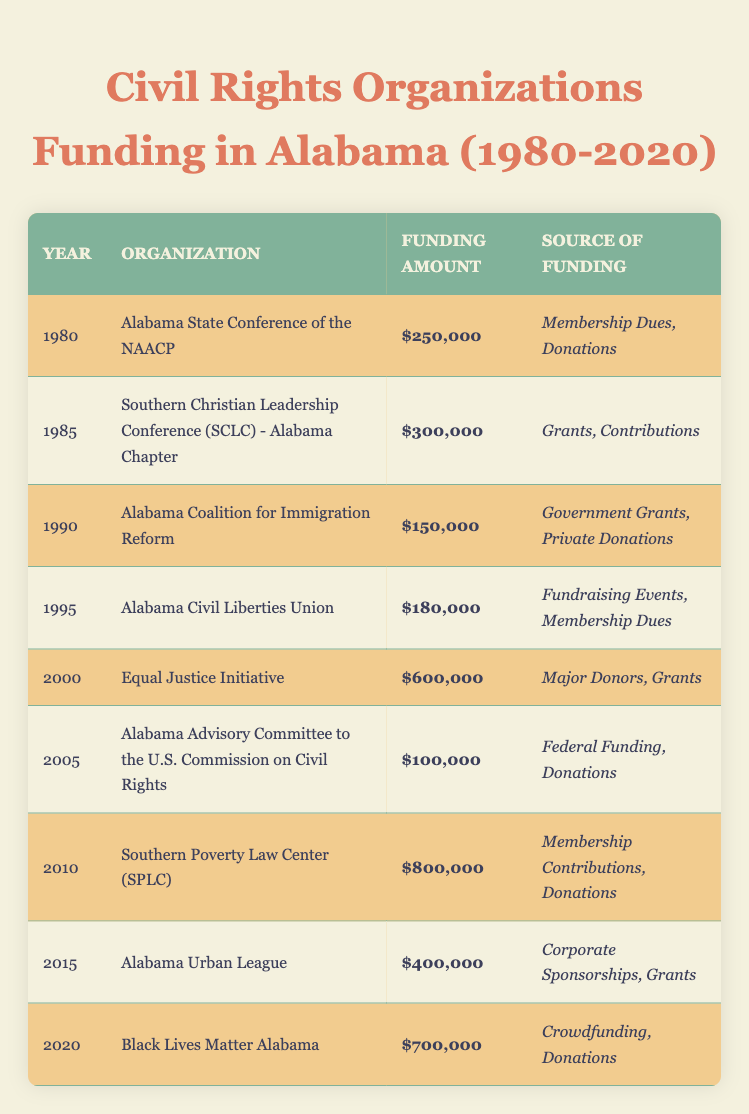What is the highest funding amount listed for a civil rights organization in Alabama between 1980 and 2020? The highest funding amount in the table is $800,000 for the Southern Poverty Law Center (SPLC) in 2010.
Answer: $800,000 Which organization received funding in 2005 and what was the amount? The Alabama Advisory Committee to the U.S. Commission on Civil Rights received $100,000 in 2005.
Answer: $100,000 What was the total funding amount for all organizations in the year 2000? In 2000, the funding amount was only $600,000 from the Equal Justice Initiative as it is the only entry for that year.
Answer: $600,000 Did the funding for the Black Lives Matter Alabama organization increase from 2015 to 2020? Yes, in 2015 the Alabama Urban League received $400,000 and in 2020 the Black Lives Matter Alabama received $700,000, showing an increase of $300,000.
Answer: Yes What is the average funding amount for civil rights organizations from 1980 to 2020? The funding amounts are $250,000, $300,000, $150,000, $180,000, $600,000, $100,000, $800,000, $400,000, and $700,000. The total is $3,480,000 and there are 9 organizations, so the average is $3,480,000 divided by 9, which equals $386,666.67.
Answer: $386,666.67 Which year saw the smallest funding amount and which organization was it? The smallest funding amount was $100,000 in 2005 for the Alabama Advisory Committee to the U.S. Commission on Civil Rights.
Answer: 2005, Alabama Advisory Committee to the U.S. Commission on Civil Rights How many organizations received funding of $600,000 or more? There are three organizations that received $600,000 or more: the Equal Justice Initiative in 2000 ($600,000), the Southern Poverty Law Center in 2010 ($800,000), and Black Lives Matter Alabama in 2020 ($700,000).
Answer: 3 What was the difference in funding between the two highest funded organizations? The difference in funding between the Southern Poverty Law Center in 2010 ($800,000) and the Black Lives Matter Alabama in 2020 ($700,000) is $800,000 - $700,000 = $100,000.
Answer: $100,000 Which organization had its funding from Government Grants and Private Donations? The Alabama Coalition for Immigration Reform had its funding sourced from Government Grants and Private Donations in 1990.
Answer: Alabama Coalition for Immigration Reform 